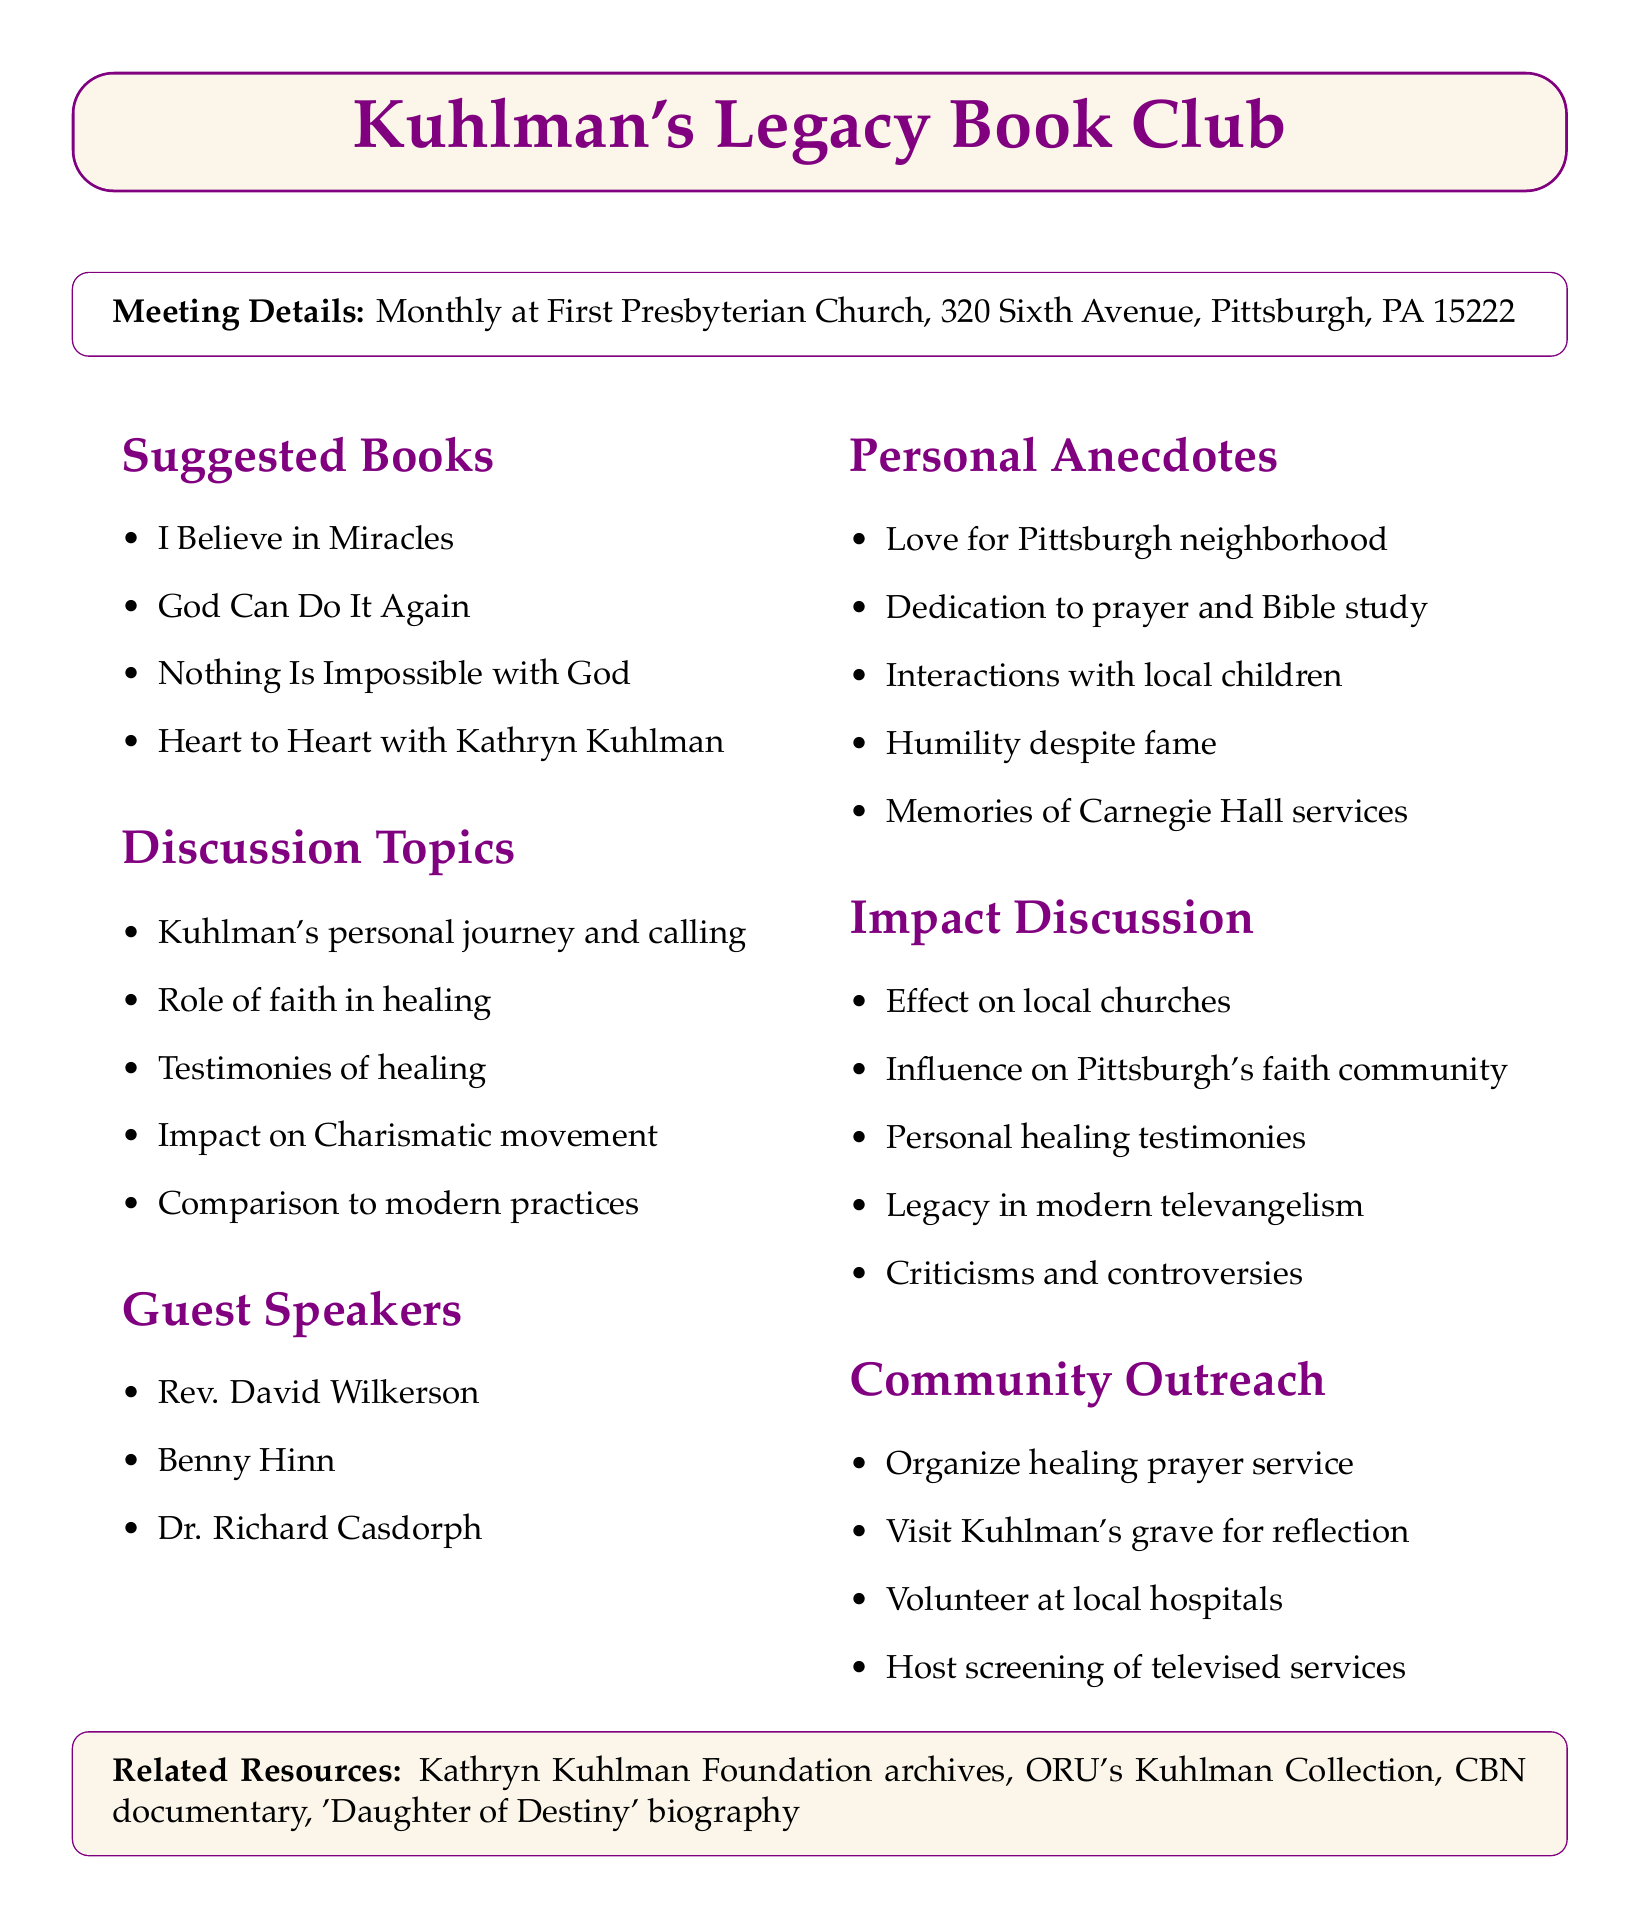What is the name of the book club? The book club is specifically named in the document, emphasizing Kathryn Kuhlman's legacy.
Answer: Kuhlman's Legacy Book Club Where will the meetings be held? The location of the meetings is outlined in the details section of the document.
Answer: First Presbyterian Church, 320 Sixth Avenue, Pittsburgh, PA 15222 How often does the book club meet? The frequency of meetings is explicitly stated in the document.
Answer: Monthly What is one suggested book for the club? The document lists several books, any of which can be mentioned.
Answer: I Believe in Miracles Who was a guest speaker mentioned in the document? The document lists notable individuals who could speak at the meetings.
Answer: Rev. David Wilkerson What is a personal anecdote shared about Kuhlman? The document includes various anecdotes that reflect Kuhlman's experiences and personality.
Answer: Her humility despite her fame What is one topic of discussion for the club? The document outlines specific topics that the club will discuss, reflecting Kuhlman's teachings and impact.
Answer: The role of faith in healing according to Kuhlman's teachings What is one community outreach activity proposed? The document proposes several outreach ideas aimed at benefiting the community.
Answer: Organize a healing prayer service in Kuhlman's style How many guests are listed in the speakers section? The document explicitly states the number of guest speakers included.
Answer: Three What is one resource related to Kathryn Kuhlman mentioned? The document lists resources that can provide further information about Kuhlman.
Answer: Kathryn Kuhlman Foundation archives 